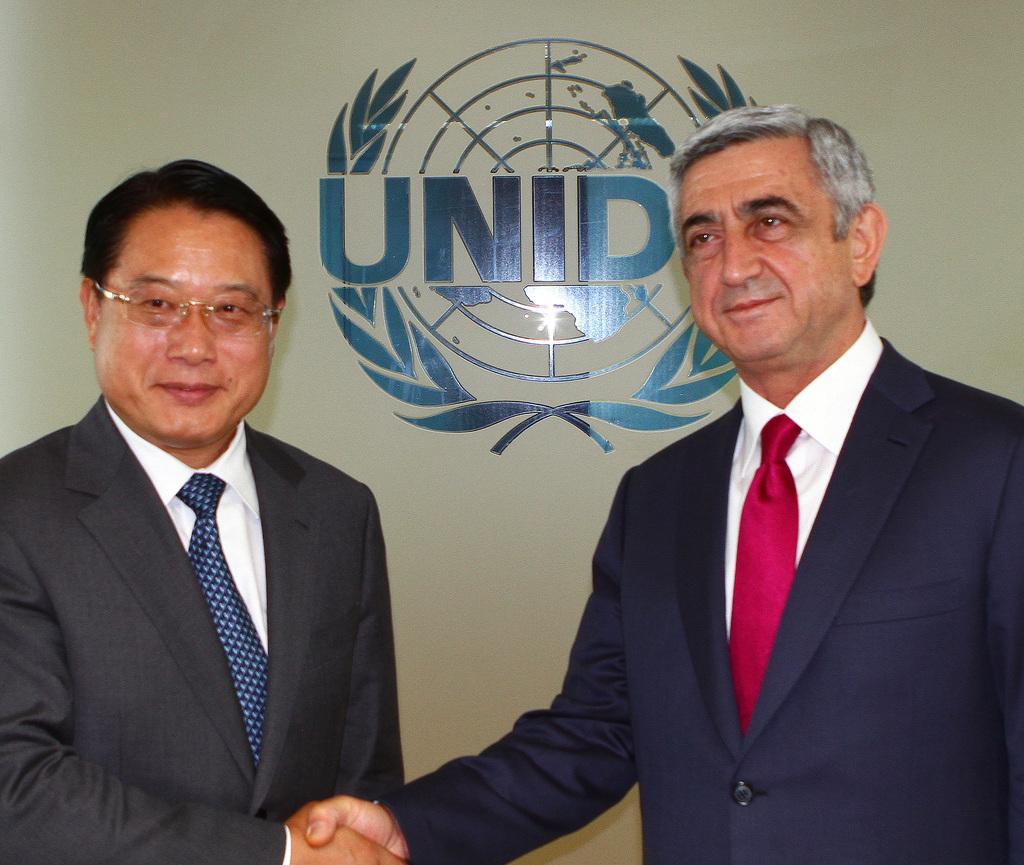Can you describe this image briefly? In the image two persons are standing and smiling. Behind them there is a wall. 